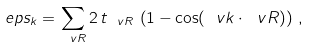<formula> <loc_0><loc_0><loc_500><loc_500>\ e p s _ { k } = \sum _ { \ v R } 2 \, t _ { \ v R } \, \left ( 1 - \cos ( \ v k \cdot \ v R ) \right ) \, ,</formula> 